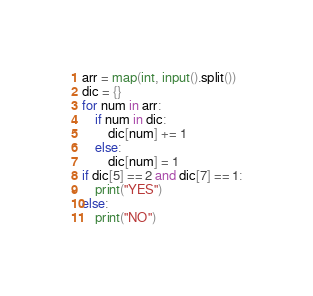<code> <loc_0><loc_0><loc_500><loc_500><_Python_>arr = map(int, input().split())
dic = {}
for num in arr:
    if num in dic:
        dic[num] += 1
    else:
        dic[num] = 1
if dic[5] == 2 and dic[7] == 1:
    print("YES")
else:
    print("NO")
</code> 